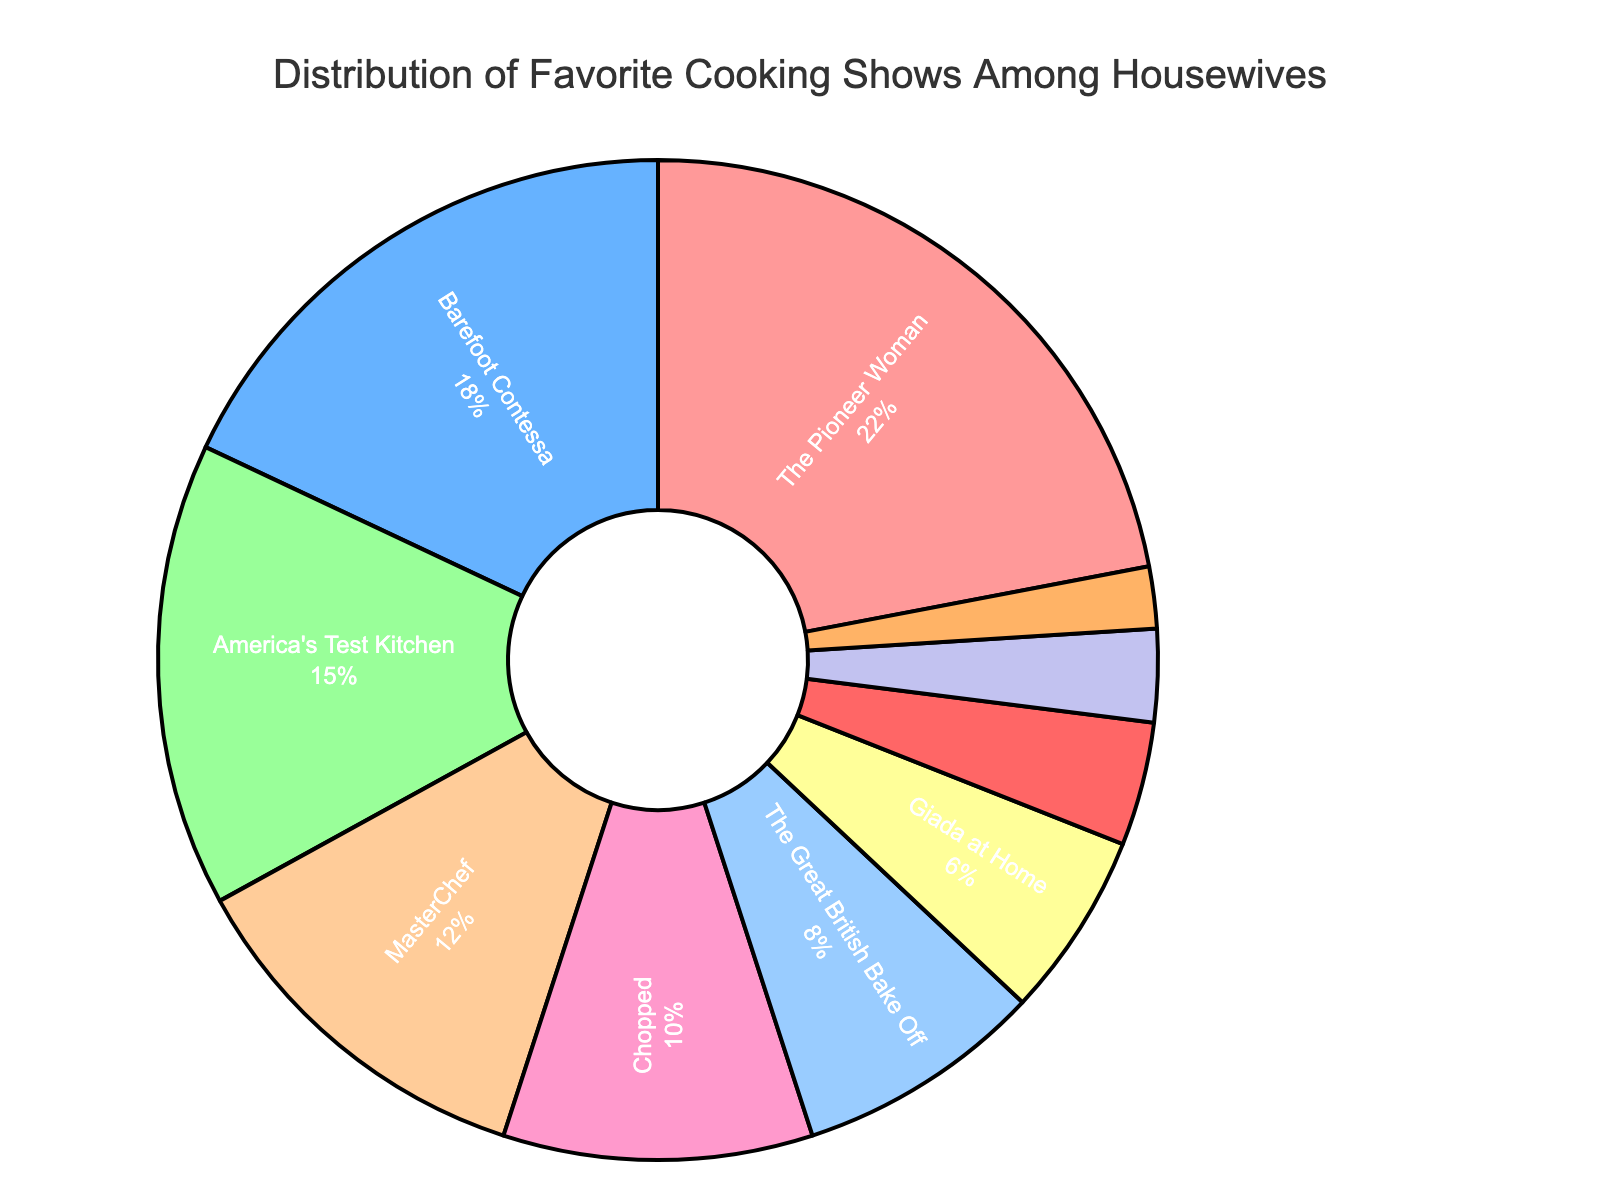What percentage of housewives prefer "The Pioneer Woman"? To find this, look at the slice of the pie chart labeled "The Pioneer Woman" and read the percentage value.
Answer: 22% Which show is more popular among housewives, "MasterChef" or "Chopped"? Compare the percentage values for "MasterChef" and "Chopped." "MasterChef" has 12%, while "Chopped" has 10%.
Answer: MasterChef What's the combined percentage of housewives that prefer "The Kitchen" and "Worst Cooks in America"? Add the percentage values for "The Kitchen" (2%) and "Worst Cooks in America" (3%). The total is 2% + 3% = 5%.
Answer: 5% What is the difference in percentage between "Barefoot Contessa" and "Giada at Home"? Subtract the percentage of "Giada at Home" (6%) from "Barefoot Contessa" (18%). The difference is 18% - 6% = 12%.
Answer: 12% Which show occupies the largest section of the pie chart? Look for the slice with the highest percentage. "The Pioneer Woman" has the largest section with 22%.
Answer: The Pioneer Woman What is the least favorite show among housewives according to this chart? Look for the slice with the smallest percentage. "The Kitchen" has the smallest slice with 2%.
Answer: The Kitchen What is the combined percentage of the three least preferred shows? Identify the three shows with the lowest percentages: "The Kitchen" (2%), "Worst Cooks in America" (3%), and "Diners, Drive-Ins and Dives" (4%). Add these percentages together: 2% + 3% + 4% = 9%.
Answer: 9% Which show ranks at the fourth position in popularity among housewives? The fourth highest value is for "MasterChef" with 12%.
Answer: MasterChef 